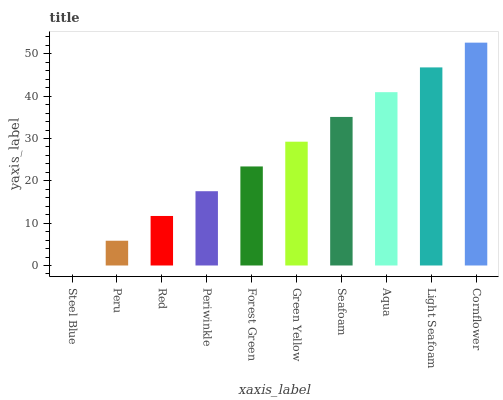Is Steel Blue the minimum?
Answer yes or no. Yes. Is Cornflower the maximum?
Answer yes or no. Yes. Is Peru the minimum?
Answer yes or no. No. Is Peru the maximum?
Answer yes or no. No. Is Peru greater than Steel Blue?
Answer yes or no. Yes. Is Steel Blue less than Peru?
Answer yes or no. Yes. Is Steel Blue greater than Peru?
Answer yes or no. No. Is Peru less than Steel Blue?
Answer yes or no. No. Is Green Yellow the high median?
Answer yes or no. Yes. Is Forest Green the low median?
Answer yes or no. Yes. Is Cornflower the high median?
Answer yes or no. No. Is Cornflower the low median?
Answer yes or no. No. 